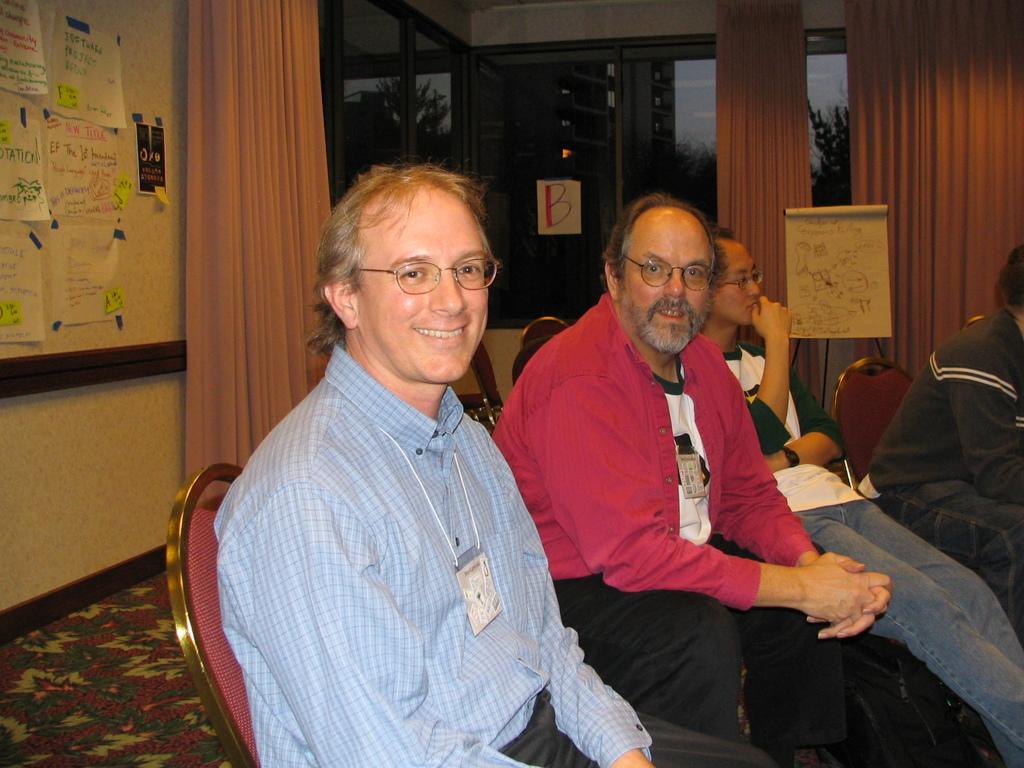Please provide a concise description of this image. Here in this picture we can see a group of people sitting on chairs which are present on the floor over there and all of them are wearing ID cards on them and smiling and behind them we can see a board, on which we can see posters present and we can see windows on the building, which are covered with curtains and through that windows we can see buildings and trees present all over there and n the middle we can see a chart board present over there. 